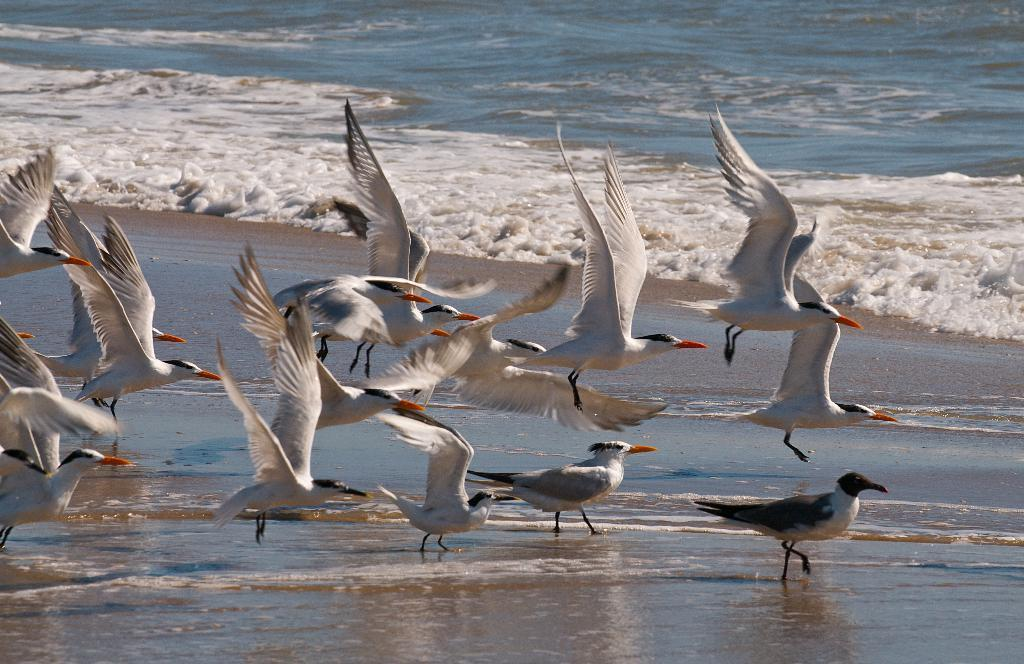What type of animals are in the water in the image? There are cranes in the water in the image. What type of apparel is the crane wearing in the image? Cranes do not wear apparel, so this question cannot be answered based on the information provided. 